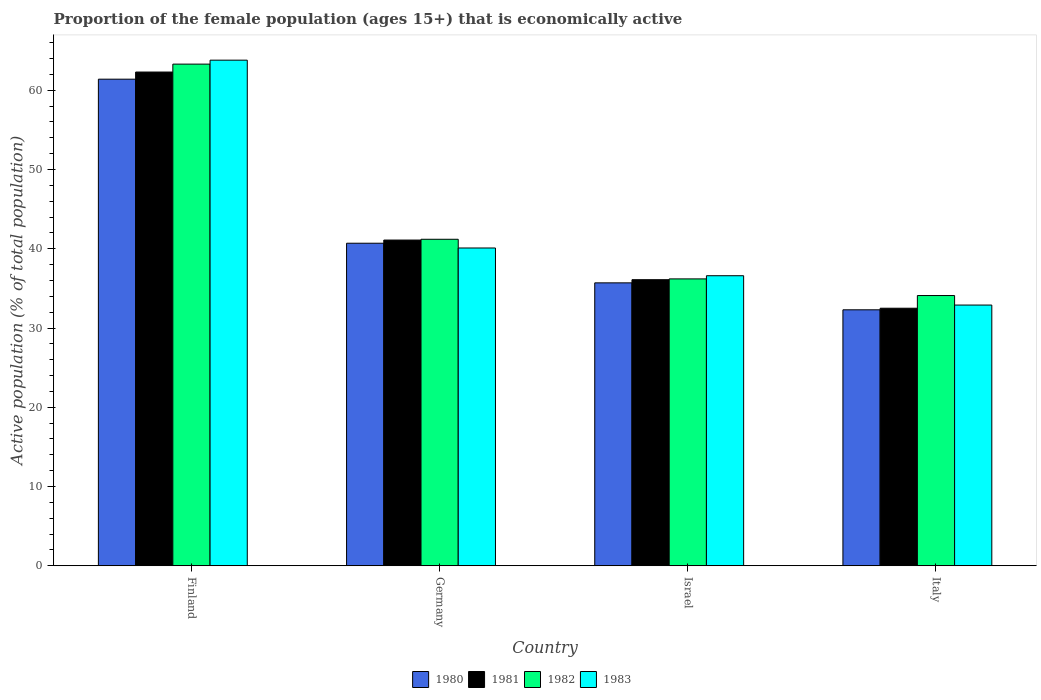Are the number of bars on each tick of the X-axis equal?
Your answer should be compact. Yes. How many bars are there on the 3rd tick from the left?
Your response must be concise. 4. How many bars are there on the 3rd tick from the right?
Provide a short and direct response. 4. In how many cases, is the number of bars for a given country not equal to the number of legend labels?
Your answer should be very brief. 0. What is the proportion of the female population that is economically active in 1980 in Israel?
Your answer should be very brief. 35.7. Across all countries, what is the maximum proportion of the female population that is economically active in 1981?
Provide a short and direct response. 62.3. Across all countries, what is the minimum proportion of the female population that is economically active in 1982?
Provide a short and direct response. 34.1. In which country was the proportion of the female population that is economically active in 1981 maximum?
Your response must be concise. Finland. In which country was the proportion of the female population that is economically active in 1982 minimum?
Provide a succinct answer. Italy. What is the total proportion of the female population that is economically active in 1981 in the graph?
Your answer should be compact. 172. What is the difference between the proportion of the female population that is economically active in 1982 in Israel and that in Italy?
Offer a very short reply. 2.1. What is the difference between the proportion of the female population that is economically active in 1983 in Israel and the proportion of the female population that is economically active in 1980 in Germany?
Give a very brief answer. -4.1. What is the average proportion of the female population that is economically active in 1981 per country?
Your response must be concise. 43. What is the difference between the proportion of the female population that is economically active of/in 1980 and proportion of the female population that is economically active of/in 1982 in Italy?
Your answer should be very brief. -1.8. In how many countries, is the proportion of the female population that is economically active in 1982 greater than 52 %?
Provide a succinct answer. 1. What is the ratio of the proportion of the female population that is economically active in 1982 in Finland to that in Israel?
Offer a very short reply. 1.75. Is the proportion of the female population that is economically active in 1981 in Israel less than that in Italy?
Your answer should be very brief. No. Is the difference between the proportion of the female population that is economically active in 1980 in Finland and Israel greater than the difference between the proportion of the female population that is economically active in 1982 in Finland and Israel?
Provide a succinct answer. No. What is the difference between the highest and the second highest proportion of the female population that is economically active in 1981?
Give a very brief answer. 5. What is the difference between the highest and the lowest proportion of the female population that is economically active in 1982?
Ensure brevity in your answer.  29.2. In how many countries, is the proportion of the female population that is economically active in 1983 greater than the average proportion of the female population that is economically active in 1983 taken over all countries?
Keep it short and to the point. 1. Is the sum of the proportion of the female population that is economically active in 1981 in Israel and Italy greater than the maximum proportion of the female population that is economically active in 1980 across all countries?
Keep it short and to the point. Yes. Is it the case that in every country, the sum of the proportion of the female population that is economically active in 1982 and proportion of the female population that is economically active in 1980 is greater than the sum of proportion of the female population that is economically active in 1981 and proportion of the female population that is economically active in 1983?
Ensure brevity in your answer.  No. What does the 4th bar from the left in Italy represents?
Provide a short and direct response. 1983. What does the 3rd bar from the right in Germany represents?
Provide a short and direct response. 1981. Are all the bars in the graph horizontal?
Your answer should be very brief. No. How many countries are there in the graph?
Provide a short and direct response. 4. What is the difference between two consecutive major ticks on the Y-axis?
Provide a succinct answer. 10. Are the values on the major ticks of Y-axis written in scientific E-notation?
Offer a very short reply. No. Does the graph contain any zero values?
Give a very brief answer. No. Does the graph contain grids?
Make the answer very short. No. Where does the legend appear in the graph?
Make the answer very short. Bottom center. How many legend labels are there?
Your answer should be very brief. 4. How are the legend labels stacked?
Keep it short and to the point. Horizontal. What is the title of the graph?
Make the answer very short. Proportion of the female population (ages 15+) that is economically active. What is the label or title of the X-axis?
Offer a terse response. Country. What is the label or title of the Y-axis?
Provide a short and direct response. Active population (% of total population). What is the Active population (% of total population) of 1980 in Finland?
Provide a short and direct response. 61.4. What is the Active population (% of total population) of 1981 in Finland?
Provide a short and direct response. 62.3. What is the Active population (% of total population) in 1982 in Finland?
Provide a succinct answer. 63.3. What is the Active population (% of total population) in 1983 in Finland?
Provide a short and direct response. 63.8. What is the Active population (% of total population) of 1980 in Germany?
Your answer should be compact. 40.7. What is the Active population (% of total population) in 1981 in Germany?
Offer a terse response. 41.1. What is the Active population (% of total population) of 1982 in Germany?
Your response must be concise. 41.2. What is the Active population (% of total population) in 1983 in Germany?
Keep it short and to the point. 40.1. What is the Active population (% of total population) of 1980 in Israel?
Your response must be concise. 35.7. What is the Active population (% of total population) in 1981 in Israel?
Your answer should be compact. 36.1. What is the Active population (% of total population) in 1982 in Israel?
Provide a short and direct response. 36.2. What is the Active population (% of total population) of 1983 in Israel?
Keep it short and to the point. 36.6. What is the Active population (% of total population) of 1980 in Italy?
Ensure brevity in your answer.  32.3. What is the Active population (% of total population) in 1981 in Italy?
Your answer should be very brief. 32.5. What is the Active population (% of total population) of 1982 in Italy?
Give a very brief answer. 34.1. What is the Active population (% of total population) of 1983 in Italy?
Your answer should be compact. 32.9. Across all countries, what is the maximum Active population (% of total population) of 1980?
Ensure brevity in your answer.  61.4. Across all countries, what is the maximum Active population (% of total population) in 1981?
Offer a very short reply. 62.3. Across all countries, what is the maximum Active population (% of total population) in 1982?
Make the answer very short. 63.3. Across all countries, what is the maximum Active population (% of total population) of 1983?
Give a very brief answer. 63.8. Across all countries, what is the minimum Active population (% of total population) in 1980?
Keep it short and to the point. 32.3. Across all countries, what is the minimum Active population (% of total population) in 1981?
Your answer should be very brief. 32.5. Across all countries, what is the minimum Active population (% of total population) in 1982?
Your answer should be very brief. 34.1. Across all countries, what is the minimum Active population (% of total population) in 1983?
Provide a succinct answer. 32.9. What is the total Active population (% of total population) in 1980 in the graph?
Keep it short and to the point. 170.1. What is the total Active population (% of total population) of 1981 in the graph?
Offer a terse response. 172. What is the total Active population (% of total population) in 1982 in the graph?
Offer a terse response. 174.8. What is the total Active population (% of total population) in 1983 in the graph?
Ensure brevity in your answer.  173.4. What is the difference between the Active population (% of total population) in 1980 in Finland and that in Germany?
Offer a terse response. 20.7. What is the difference between the Active population (% of total population) of 1981 in Finland and that in Germany?
Your answer should be compact. 21.2. What is the difference between the Active population (% of total population) in 1982 in Finland and that in Germany?
Offer a terse response. 22.1. What is the difference between the Active population (% of total population) in 1983 in Finland and that in Germany?
Your response must be concise. 23.7. What is the difference between the Active population (% of total population) of 1980 in Finland and that in Israel?
Make the answer very short. 25.7. What is the difference between the Active population (% of total population) in 1981 in Finland and that in Israel?
Ensure brevity in your answer.  26.2. What is the difference between the Active population (% of total population) of 1982 in Finland and that in Israel?
Offer a terse response. 27.1. What is the difference between the Active population (% of total population) in 1983 in Finland and that in Israel?
Provide a short and direct response. 27.2. What is the difference between the Active population (% of total population) in 1980 in Finland and that in Italy?
Give a very brief answer. 29.1. What is the difference between the Active population (% of total population) of 1981 in Finland and that in Italy?
Offer a very short reply. 29.8. What is the difference between the Active population (% of total population) of 1982 in Finland and that in Italy?
Offer a very short reply. 29.2. What is the difference between the Active population (% of total population) in 1983 in Finland and that in Italy?
Provide a succinct answer. 30.9. What is the difference between the Active population (% of total population) of 1980 in Germany and that in Israel?
Keep it short and to the point. 5. What is the difference between the Active population (% of total population) of 1981 in Germany and that in Israel?
Provide a succinct answer. 5. What is the difference between the Active population (% of total population) in 1982 in Germany and that in Israel?
Offer a very short reply. 5. What is the difference between the Active population (% of total population) in 1981 in Germany and that in Italy?
Your response must be concise. 8.6. What is the difference between the Active population (% of total population) of 1982 in Germany and that in Italy?
Offer a very short reply. 7.1. What is the difference between the Active population (% of total population) of 1980 in Israel and that in Italy?
Provide a short and direct response. 3.4. What is the difference between the Active population (% of total population) in 1980 in Finland and the Active population (% of total population) in 1981 in Germany?
Provide a succinct answer. 20.3. What is the difference between the Active population (% of total population) in 1980 in Finland and the Active population (% of total population) in 1982 in Germany?
Your answer should be very brief. 20.2. What is the difference between the Active population (% of total population) in 1980 in Finland and the Active population (% of total population) in 1983 in Germany?
Make the answer very short. 21.3. What is the difference between the Active population (% of total population) of 1981 in Finland and the Active population (% of total population) of 1982 in Germany?
Provide a succinct answer. 21.1. What is the difference between the Active population (% of total population) in 1982 in Finland and the Active population (% of total population) in 1983 in Germany?
Offer a terse response. 23.2. What is the difference between the Active population (% of total population) of 1980 in Finland and the Active population (% of total population) of 1981 in Israel?
Ensure brevity in your answer.  25.3. What is the difference between the Active population (% of total population) of 1980 in Finland and the Active population (% of total population) of 1982 in Israel?
Offer a terse response. 25.2. What is the difference between the Active population (% of total population) of 1980 in Finland and the Active population (% of total population) of 1983 in Israel?
Your response must be concise. 24.8. What is the difference between the Active population (% of total population) in 1981 in Finland and the Active population (% of total population) in 1982 in Israel?
Keep it short and to the point. 26.1. What is the difference between the Active population (% of total population) in 1981 in Finland and the Active population (% of total population) in 1983 in Israel?
Your response must be concise. 25.7. What is the difference between the Active population (% of total population) of 1982 in Finland and the Active population (% of total population) of 1983 in Israel?
Your answer should be compact. 26.7. What is the difference between the Active population (% of total population) of 1980 in Finland and the Active population (% of total population) of 1981 in Italy?
Your answer should be compact. 28.9. What is the difference between the Active population (% of total population) of 1980 in Finland and the Active population (% of total population) of 1982 in Italy?
Ensure brevity in your answer.  27.3. What is the difference between the Active population (% of total population) of 1980 in Finland and the Active population (% of total population) of 1983 in Italy?
Offer a very short reply. 28.5. What is the difference between the Active population (% of total population) of 1981 in Finland and the Active population (% of total population) of 1982 in Italy?
Your answer should be very brief. 28.2. What is the difference between the Active population (% of total population) in 1981 in Finland and the Active population (% of total population) in 1983 in Italy?
Give a very brief answer. 29.4. What is the difference between the Active population (% of total population) in 1982 in Finland and the Active population (% of total population) in 1983 in Italy?
Your response must be concise. 30.4. What is the difference between the Active population (% of total population) in 1980 in Germany and the Active population (% of total population) in 1981 in Israel?
Give a very brief answer. 4.6. What is the difference between the Active population (% of total population) in 1980 in Germany and the Active population (% of total population) in 1982 in Israel?
Provide a short and direct response. 4.5. What is the difference between the Active population (% of total population) of 1981 in Germany and the Active population (% of total population) of 1983 in Israel?
Provide a succinct answer. 4.5. What is the difference between the Active population (% of total population) of 1980 in Germany and the Active population (% of total population) of 1981 in Italy?
Keep it short and to the point. 8.2. What is the difference between the Active population (% of total population) of 1980 in Germany and the Active population (% of total population) of 1982 in Italy?
Provide a short and direct response. 6.6. What is the difference between the Active population (% of total population) in 1980 in Germany and the Active population (% of total population) in 1983 in Italy?
Provide a short and direct response. 7.8. What is the difference between the Active population (% of total population) in 1982 in Germany and the Active population (% of total population) in 1983 in Italy?
Offer a terse response. 8.3. What is the difference between the Active population (% of total population) in 1980 in Israel and the Active population (% of total population) in 1981 in Italy?
Offer a terse response. 3.2. What is the difference between the Active population (% of total population) in 1981 in Israel and the Active population (% of total population) in 1983 in Italy?
Provide a succinct answer. 3.2. What is the difference between the Active population (% of total population) in 1982 in Israel and the Active population (% of total population) in 1983 in Italy?
Your answer should be compact. 3.3. What is the average Active population (% of total population) of 1980 per country?
Make the answer very short. 42.52. What is the average Active population (% of total population) of 1982 per country?
Your answer should be compact. 43.7. What is the average Active population (% of total population) in 1983 per country?
Give a very brief answer. 43.35. What is the difference between the Active population (% of total population) in 1980 and Active population (% of total population) in 1981 in Germany?
Make the answer very short. -0.4. What is the difference between the Active population (% of total population) in 1980 and Active population (% of total population) in 1982 in Germany?
Your answer should be very brief. -0.5. What is the difference between the Active population (% of total population) of 1981 and Active population (% of total population) of 1982 in Germany?
Ensure brevity in your answer.  -0.1. What is the difference between the Active population (% of total population) in 1981 and Active population (% of total population) in 1983 in Germany?
Your answer should be compact. 1. What is the difference between the Active population (% of total population) in 1980 and Active population (% of total population) in 1981 in Israel?
Your answer should be very brief. -0.4. What is the difference between the Active population (% of total population) in 1980 and Active population (% of total population) in 1982 in Israel?
Your answer should be compact. -0.5. What is the difference between the Active population (% of total population) of 1980 and Active population (% of total population) of 1982 in Italy?
Your answer should be very brief. -1.8. What is the difference between the Active population (% of total population) of 1980 and Active population (% of total population) of 1983 in Italy?
Offer a very short reply. -0.6. What is the difference between the Active population (% of total population) in 1982 and Active population (% of total population) in 1983 in Italy?
Your response must be concise. 1.2. What is the ratio of the Active population (% of total population) in 1980 in Finland to that in Germany?
Your response must be concise. 1.51. What is the ratio of the Active population (% of total population) of 1981 in Finland to that in Germany?
Provide a succinct answer. 1.52. What is the ratio of the Active population (% of total population) of 1982 in Finland to that in Germany?
Give a very brief answer. 1.54. What is the ratio of the Active population (% of total population) of 1983 in Finland to that in Germany?
Keep it short and to the point. 1.59. What is the ratio of the Active population (% of total population) of 1980 in Finland to that in Israel?
Your answer should be compact. 1.72. What is the ratio of the Active population (% of total population) of 1981 in Finland to that in Israel?
Your response must be concise. 1.73. What is the ratio of the Active population (% of total population) of 1982 in Finland to that in Israel?
Give a very brief answer. 1.75. What is the ratio of the Active population (% of total population) of 1983 in Finland to that in Israel?
Your answer should be compact. 1.74. What is the ratio of the Active population (% of total population) in 1980 in Finland to that in Italy?
Offer a very short reply. 1.9. What is the ratio of the Active population (% of total population) of 1981 in Finland to that in Italy?
Your response must be concise. 1.92. What is the ratio of the Active population (% of total population) in 1982 in Finland to that in Italy?
Your response must be concise. 1.86. What is the ratio of the Active population (% of total population) in 1983 in Finland to that in Italy?
Your response must be concise. 1.94. What is the ratio of the Active population (% of total population) in 1980 in Germany to that in Israel?
Your response must be concise. 1.14. What is the ratio of the Active population (% of total population) in 1981 in Germany to that in Israel?
Offer a very short reply. 1.14. What is the ratio of the Active population (% of total population) of 1982 in Germany to that in Israel?
Provide a short and direct response. 1.14. What is the ratio of the Active population (% of total population) in 1983 in Germany to that in Israel?
Offer a very short reply. 1.1. What is the ratio of the Active population (% of total population) of 1980 in Germany to that in Italy?
Keep it short and to the point. 1.26. What is the ratio of the Active population (% of total population) in 1981 in Germany to that in Italy?
Your response must be concise. 1.26. What is the ratio of the Active population (% of total population) of 1982 in Germany to that in Italy?
Ensure brevity in your answer.  1.21. What is the ratio of the Active population (% of total population) in 1983 in Germany to that in Italy?
Offer a very short reply. 1.22. What is the ratio of the Active population (% of total population) in 1980 in Israel to that in Italy?
Your answer should be very brief. 1.11. What is the ratio of the Active population (% of total population) of 1981 in Israel to that in Italy?
Keep it short and to the point. 1.11. What is the ratio of the Active population (% of total population) of 1982 in Israel to that in Italy?
Ensure brevity in your answer.  1.06. What is the ratio of the Active population (% of total population) in 1983 in Israel to that in Italy?
Your answer should be very brief. 1.11. What is the difference between the highest and the second highest Active population (% of total population) in 1980?
Give a very brief answer. 20.7. What is the difference between the highest and the second highest Active population (% of total population) in 1981?
Keep it short and to the point. 21.2. What is the difference between the highest and the second highest Active population (% of total population) in 1982?
Keep it short and to the point. 22.1. What is the difference between the highest and the second highest Active population (% of total population) of 1983?
Provide a short and direct response. 23.7. What is the difference between the highest and the lowest Active population (% of total population) in 1980?
Your answer should be compact. 29.1. What is the difference between the highest and the lowest Active population (% of total population) of 1981?
Your answer should be very brief. 29.8. What is the difference between the highest and the lowest Active population (% of total population) of 1982?
Offer a very short reply. 29.2. What is the difference between the highest and the lowest Active population (% of total population) of 1983?
Your answer should be compact. 30.9. 